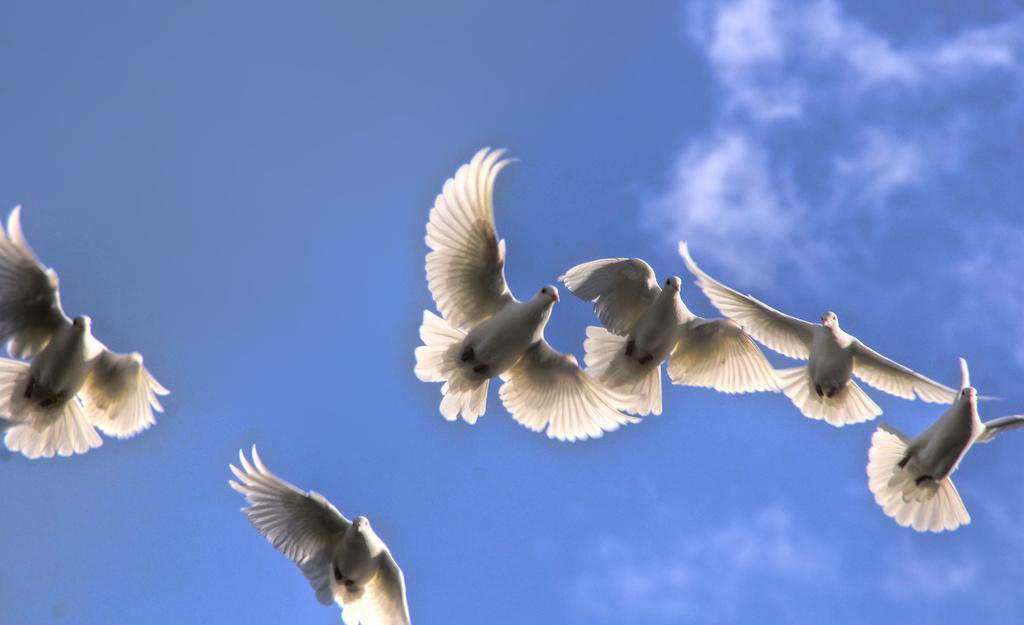Please provide a concise description of this image. This picture is clicked outside and we can see the group of pigeons flying in the air. In the background we can see the sky with some clouds. 